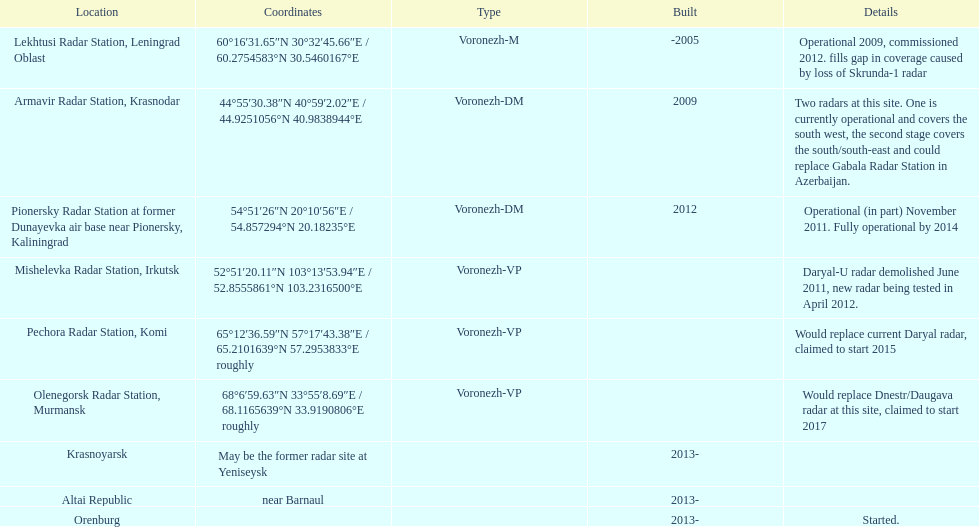Which site has the most radars? Armavir Radar Station, Krasnodar. 